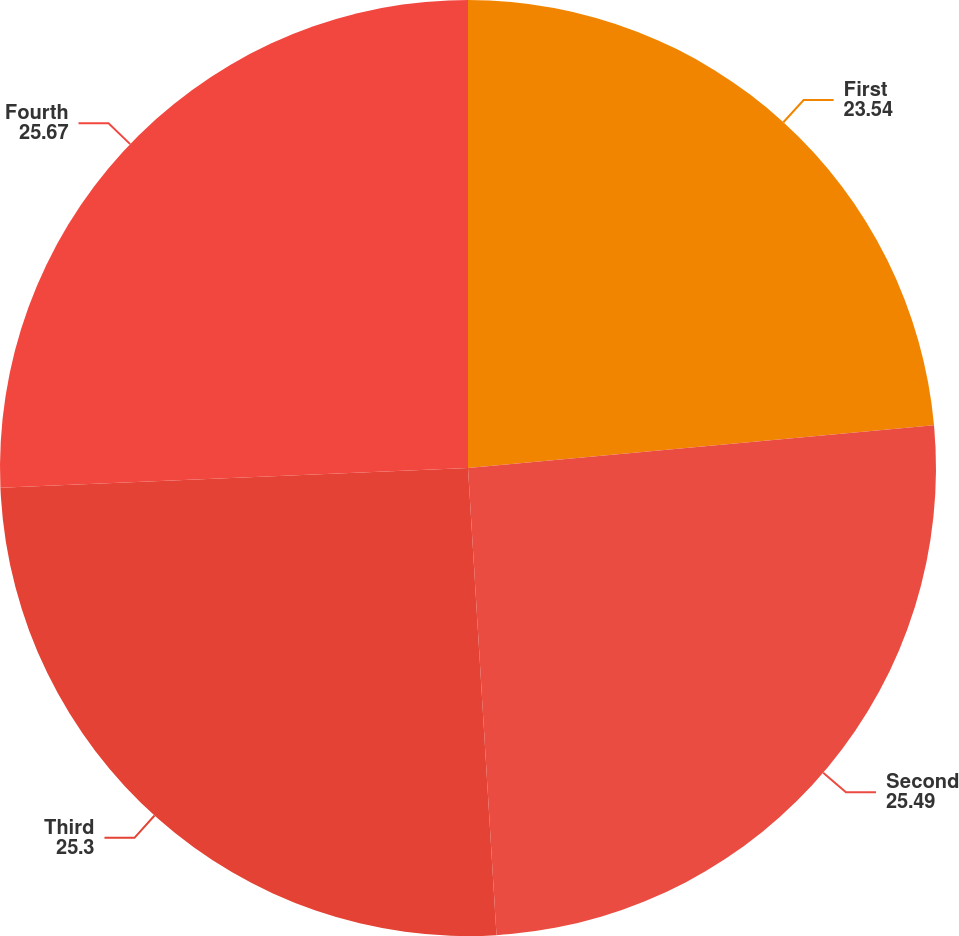Convert chart. <chart><loc_0><loc_0><loc_500><loc_500><pie_chart><fcel>First<fcel>Second<fcel>Third<fcel>Fourth<nl><fcel>23.54%<fcel>25.49%<fcel>25.3%<fcel>25.67%<nl></chart> 